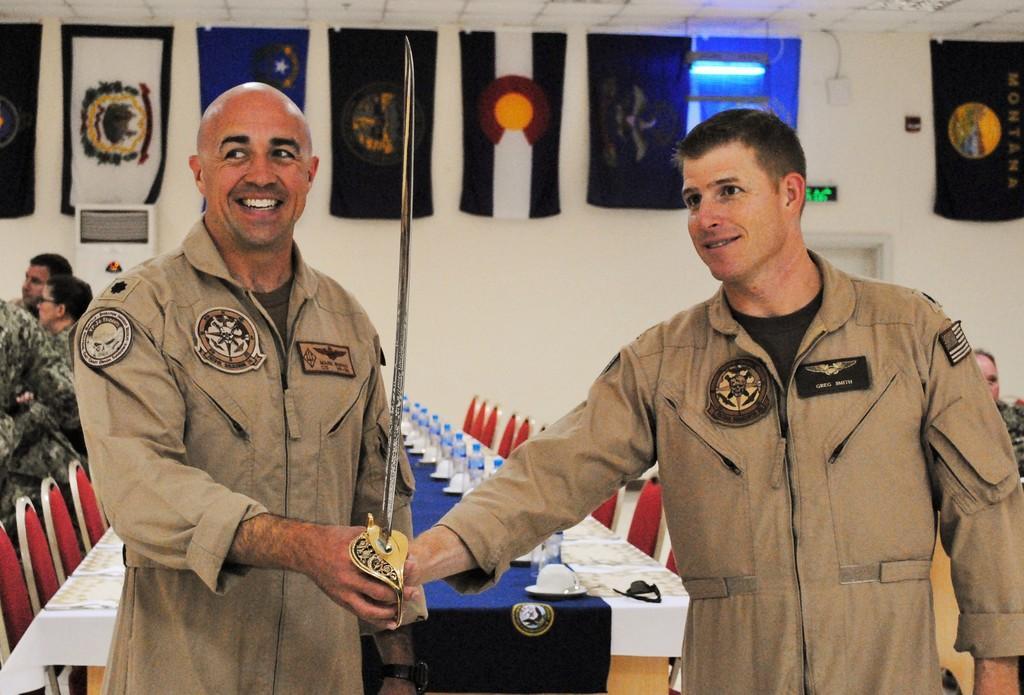In one or two sentences, can you explain what this image depicts? This image consists of two persons wearing brown coats are holding a sword. In the background, there is a table covered with a white cloth. On which there are bottles and plates kept. In the background, there is a wall on which, there are flags. On the left, there are three persons. 